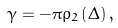<formula> <loc_0><loc_0><loc_500><loc_500>\gamma = - \pi \rho _ { 2 } \left ( \Delta \right ) ,</formula> 